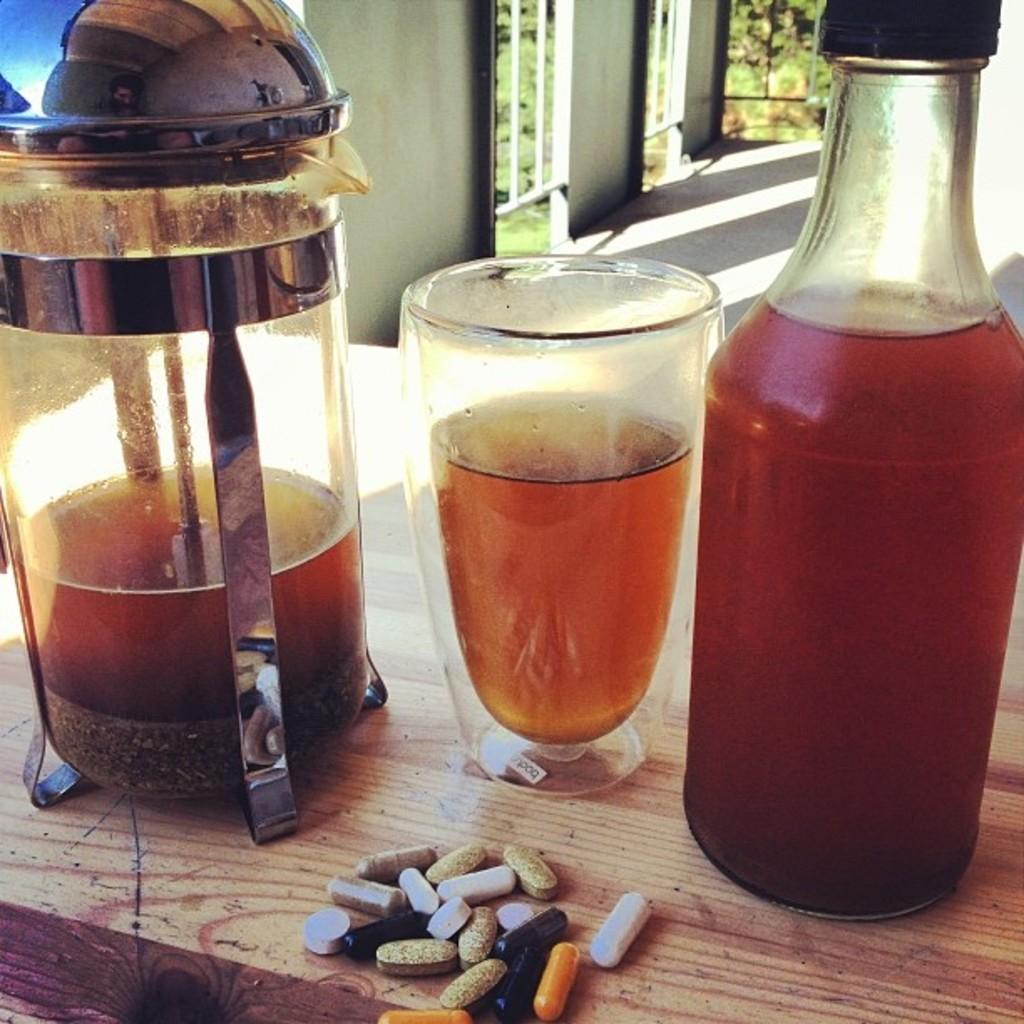What type of container is visible in the image? There is a bottle, a glass, and a jar in the image. What are the pills in the image used for? The purpose of the pills cannot be determined from the image alone. Where are the objects located in the image? The objects are on a table in the image. What can be seen through the window in the background of the image? Trees are visible through the window in the background of the image. What is the background of the image composed of? The background of the image includes a window, trees, and a wall. Can you hear the jellyfish crying in the image? There are no jellyfish or sounds in the image, so it is not possible to hear any crying. 